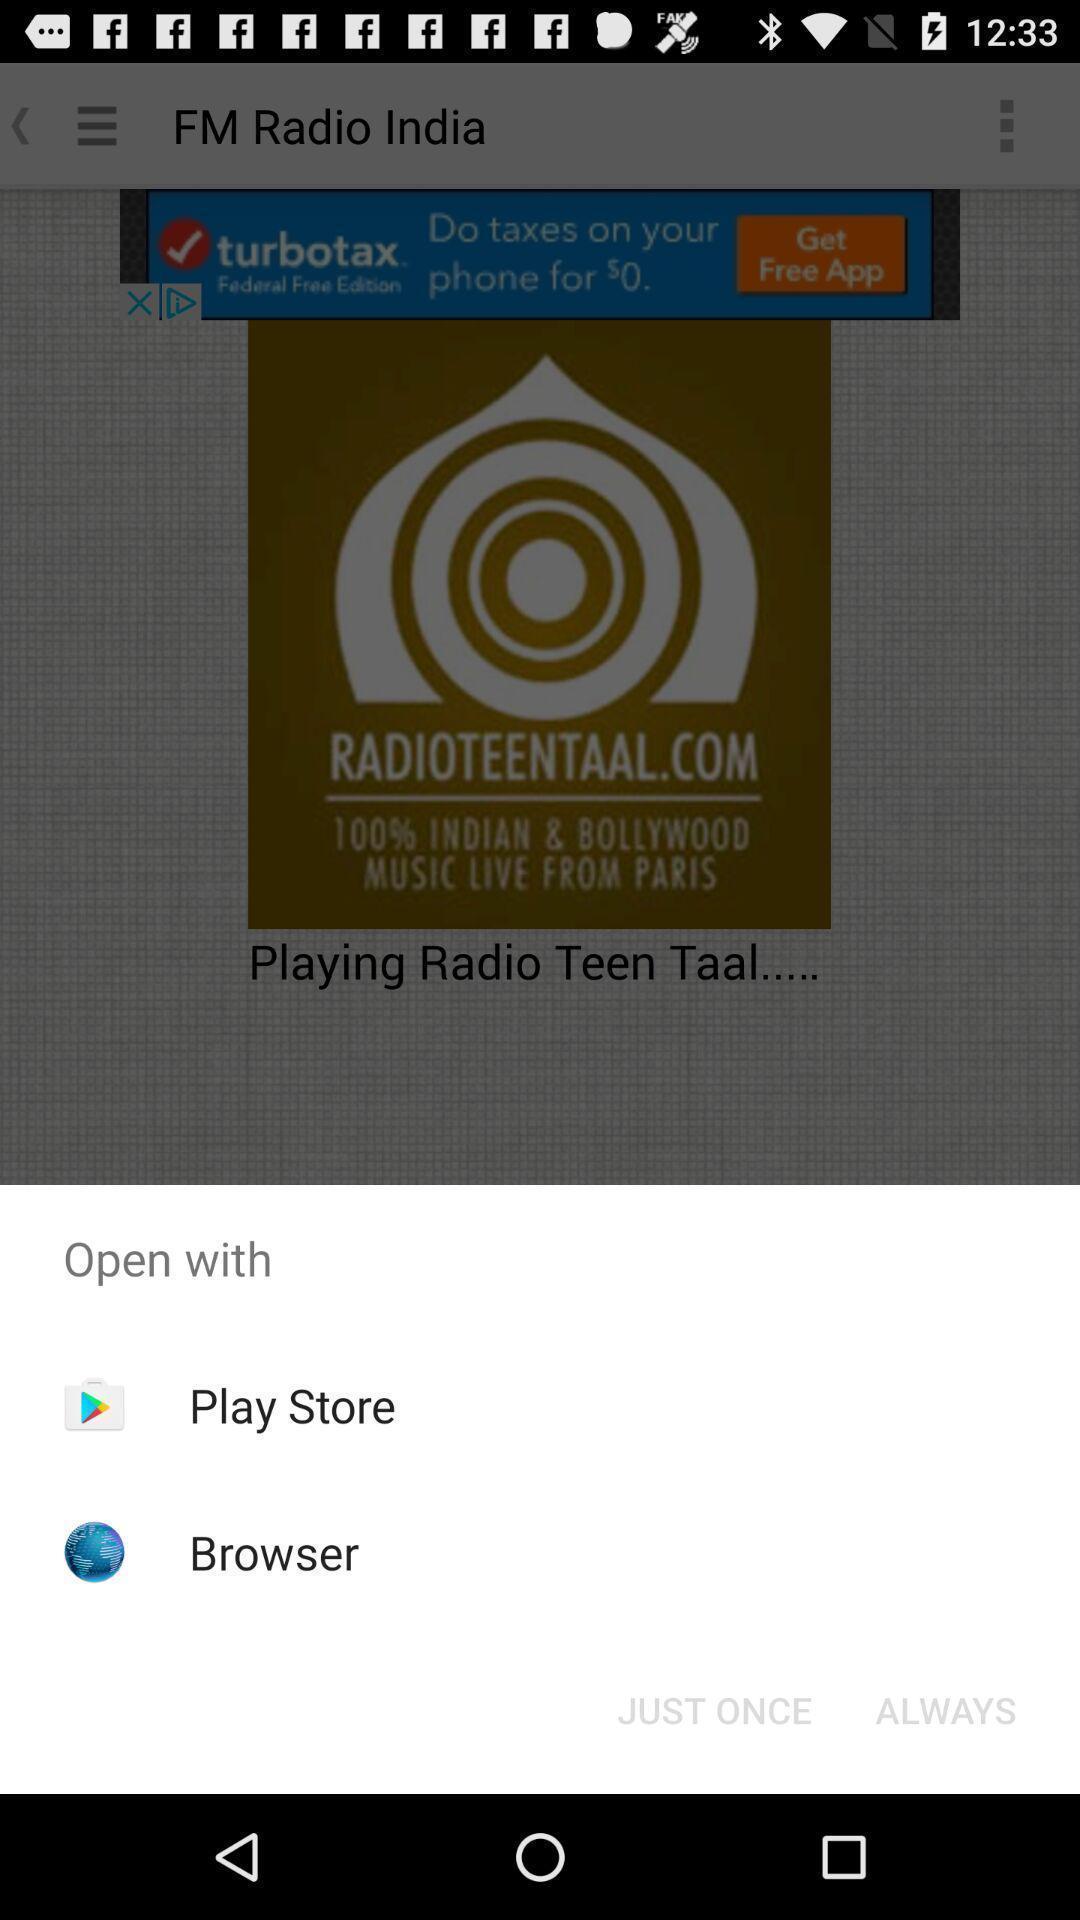Explain the elements present in this screenshot. Popup to open with different options in the radio app. 